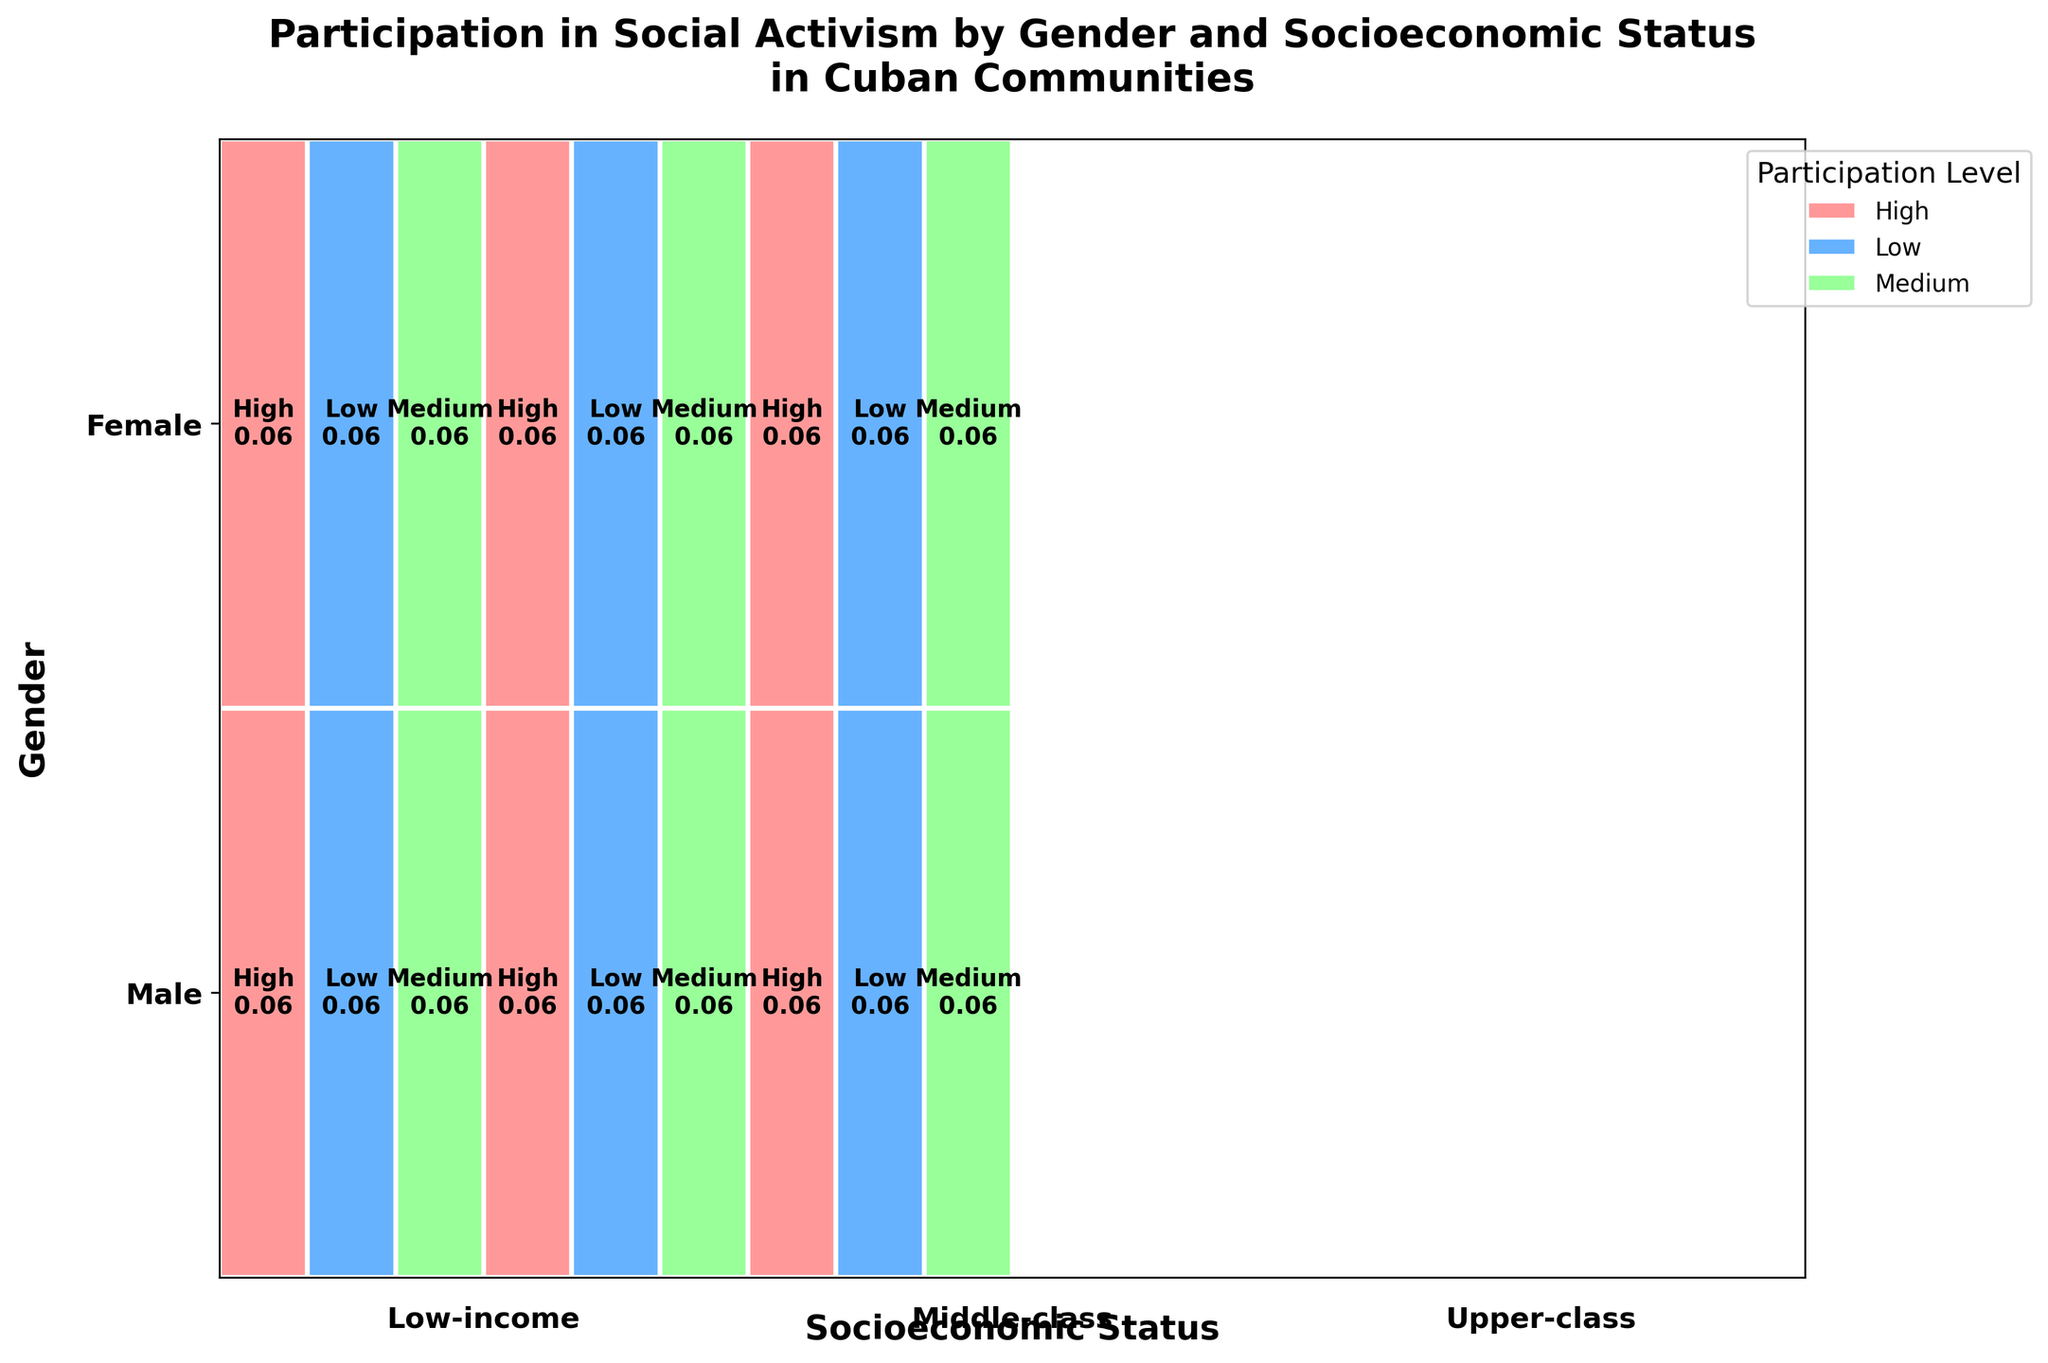What is the title of the figure? The title is usually found at the top of the plot.
Answer: Participation in Social Activism by Gender and Socioeconomic Status in Cuban Communities Which participation level has the highest representation for males in the middle-class group? Look at the section corresponding to males and middle-class socioeconomic status, then identify which participation level has the largest width.
Answer: High Are upper-class males more likely to have a high or low participation level in social activism? Compare the widths of the rectangles corresponding to high and low participation levels for males in the upper-class socioeconomic status.
Answer: High Is there a gender that has higher participation in social activism in all socioeconomic groups? Look at the widths of the rectangles for both genders across all socioeconomic statuses and compare their proportions.
Answer: No How many distinct socioeconomic statuses are represented in the plot? Identify the labels or sections along the socioeconomic status axis.
Answer: Three For females, which socioeconomic group has the highest level of participation in social activism? Identify the section for females and compare the widths of the 'High' participation level across all socioeconomic statuses.
Answer: Low-income Do males or females have higher participation levels in the low-income group? Compare the widths of the 'High' participation level rectangles for both genders in the low-income section.
Answer: Females What are the participation levels represented by the different colors in the plot? Look at the legend on the plot and match the colors with the corresponding participation levels.
Answer: High, Medium, Low Which gender in the middle-class has the lowest participation in social activism? Identify the middle-class section and compare the widths of the 'Low' participation level rectangles for both genders.
Answer: Equal For which gender and socioeconomic status combination is medium participation in social activism the lowest? Compare the widths of the 'Medium' participation level rectangles across all gender and socioeconomic status combinations.
Answer: Female, Low-income 